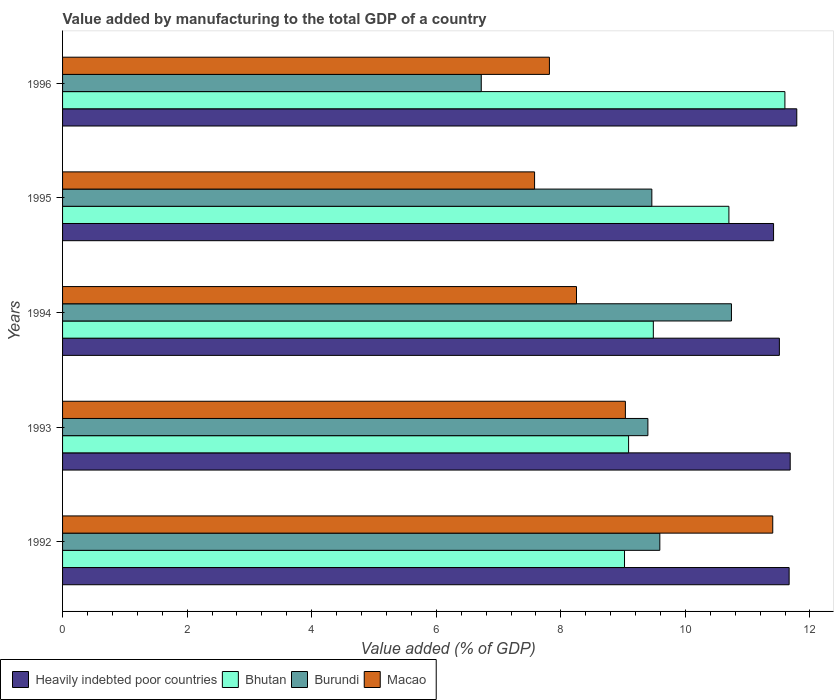How many groups of bars are there?
Your answer should be compact. 5. Are the number of bars per tick equal to the number of legend labels?
Provide a short and direct response. Yes. Are the number of bars on each tick of the Y-axis equal?
Make the answer very short. Yes. In how many cases, is the number of bars for a given year not equal to the number of legend labels?
Your answer should be compact. 0. What is the value added by manufacturing to the total GDP in Bhutan in 1995?
Provide a short and direct response. 10.7. Across all years, what is the maximum value added by manufacturing to the total GDP in Macao?
Offer a terse response. 11.4. Across all years, what is the minimum value added by manufacturing to the total GDP in Burundi?
Offer a very short reply. 6.72. What is the total value added by manufacturing to the total GDP in Macao in the graph?
Provide a short and direct response. 44.09. What is the difference between the value added by manufacturing to the total GDP in Burundi in 1993 and that in 1996?
Ensure brevity in your answer.  2.68. What is the difference between the value added by manufacturing to the total GDP in Burundi in 1993 and the value added by manufacturing to the total GDP in Macao in 1994?
Provide a short and direct response. 1.15. What is the average value added by manufacturing to the total GDP in Bhutan per year?
Offer a terse response. 9.98. In the year 1994, what is the difference between the value added by manufacturing to the total GDP in Bhutan and value added by manufacturing to the total GDP in Burundi?
Your answer should be very brief. -1.25. What is the ratio of the value added by manufacturing to the total GDP in Macao in 1993 to that in 1994?
Offer a very short reply. 1.1. Is the value added by manufacturing to the total GDP in Burundi in 1994 less than that in 1996?
Give a very brief answer. No. What is the difference between the highest and the second highest value added by manufacturing to the total GDP in Macao?
Your response must be concise. 2.37. What is the difference between the highest and the lowest value added by manufacturing to the total GDP in Macao?
Provide a succinct answer. 3.82. In how many years, is the value added by manufacturing to the total GDP in Heavily indebted poor countries greater than the average value added by manufacturing to the total GDP in Heavily indebted poor countries taken over all years?
Make the answer very short. 3. Is the sum of the value added by manufacturing to the total GDP in Macao in 1994 and 1996 greater than the maximum value added by manufacturing to the total GDP in Heavily indebted poor countries across all years?
Offer a terse response. Yes. What does the 4th bar from the top in 1992 represents?
Your response must be concise. Heavily indebted poor countries. What does the 1st bar from the bottom in 1993 represents?
Your response must be concise. Heavily indebted poor countries. Does the graph contain any zero values?
Provide a short and direct response. No. Does the graph contain grids?
Give a very brief answer. No. How many legend labels are there?
Your response must be concise. 4. How are the legend labels stacked?
Ensure brevity in your answer.  Horizontal. What is the title of the graph?
Your response must be concise. Value added by manufacturing to the total GDP of a country. Does "Least developed countries" appear as one of the legend labels in the graph?
Make the answer very short. No. What is the label or title of the X-axis?
Offer a very short reply. Value added (% of GDP). What is the label or title of the Y-axis?
Provide a succinct answer. Years. What is the Value added (% of GDP) in Heavily indebted poor countries in 1992?
Your response must be concise. 11.67. What is the Value added (% of GDP) of Bhutan in 1992?
Give a very brief answer. 9.02. What is the Value added (% of GDP) of Burundi in 1992?
Your answer should be compact. 9.59. What is the Value added (% of GDP) in Macao in 1992?
Your answer should be compact. 11.4. What is the Value added (% of GDP) of Heavily indebted poor countries in 1993?
Offer a very short reply. 11.68. What is the Value added (% of GDP) of Bhutan in 1993?
Provide a short and direct response. 9.09. What is the Value added (% of GDP) of Burundi in 1993?
Your answer should be compact. 9.4. What is the Value added (% of GDP) of Macao in 1993?
Provide a succinct answer. 9.04. What is the Value added (% of GDP) in Heavily indebted poor countries in 1994?
Give a very brief answer. 11.51. What is the Value added (% of GDP) of Bhutan in 1994?
Your response must be concise. 9.49. What is the Value added (% of GDP) of Burundi in 1994?
Your answer should be very brief. 10.74. What is the Value added (% of GDP) in Macao in 1994?
Keep it short and to the point. 8.25. What is the Value added (% of GDP) of Heavily indebted poor countries in 1995?
Provide a short and direct response. 11.42. What is the Value added (% of GDP) in Bhutan in 1995?
Your answer should be compact. 10.7. What is the Value added (% of GDP) in Burundi in 1995?
Give a very brief answer. 9.46. What is the Value added (% of GDP) of Macao in 1995?
Make the answer very short. 7.58. What is the Value added (% of GDP) in Heavily indebted poor countries in 1996?
Ensure brevity in your answer.  11.79. What is the Value added (% of GDP) of Bhutan in 1996?
Your answer should be compact. 11.6. What is the Value added (% of GDP) of Burundi in 1996?
Offer a terse response. 6.72. What is the Value added (% of GDP) of Macao in 1996?
Your answer should be compact. 7.82. Across all years, what is the maximum Value added (% of GDP) of Heavily indebted poor countries?
Offer a very short reply. 11.79. Across all years, what is the maximum Value added (% of GDP) of Bhutan?
Offer a very short reply. 11.6. Across all years, what is the maximum Value added (% of GDP) in Burundi?
Ensure brevity in your answer.  10.74. Across all years, what is the maximum Value added (% of GDP) of Macao?
Keep it short and to the point. 11.4. Across all years, what is the minimum Value added (% of GDP) in Heavily indebted poor countries?
Offer a very short reply. 11.42. Across all years, what is the minimum Value added (% of GDP) in Bhutan?
Offer a very short reply. 9.02. Across all years, what is the minimum Value added (% of GDP) of Burundi?
Make the answer very short. 6.72. Across all years, what is the minimum Value added (% of GDP) in Macao?
Provide a short and direct response. 7.58. What is the total Value added (% of GDP) in Heavily indebted poor countries in the graph?
Make the answer very short. 58.06. What is the total Value added (% of GDP) of Bhutan in the graph?
Your answer should be very brief. 49.89. What is the total Value added (% of GDP) in Burundi in the graph?
Your response must be concise. 45.91. What is the total Value added (% of GDP) in Macao in the graph?
Your answer should be compact. 44.09. What is the difference between the Value added (% of GDP) in Heavily indebted poor countries in 1992 and that in 1993?
Your answer should be compact. -0.02. What is the difference between the Value added (% of GDP) of Bhutan in 1992 and that in 1993?
Provide a short and direct response. -0.07. What is the difference between the Value added (% of GDP) of Burundi in 1992 and that in 1993?
Your answer should be compact. 0.19. What is the difference between the Value added (% of GDP) of Macao in 1992 and that in 1993?
Offer a very short reply. 2.37. What is the difference between the Value added (% of GDP) of Heavily indebted poor countries in 1992 and that in 1994?
Keep it short and to the point. 0.16. What is the difference between the Value added (% of GDP) of Bhutan in 1992 and that in 1994?
Ensure brevity in your answer.  -0.46. What is the difference between the Value added (% of GDP) in Burundi in 1992 and that in 1994?
Your response must be concise. -1.15. What is the difference between the Value added (% of GDP) of Macao in 1992 and that in 1994?
Your answer should be very brief. 3.15. What is the difference between the Value added (% of GDP) of Heavily indebted poor countries in 1992 and that in 1995?
Your response must be concise. 0.25. What is the difference between the Value added (% of GDP) of Bhutan in 1992 and that in 1995?
Your response must be concise. -1.68. What is the difference between the Value added (% of GDP) of Burundi in 1992 and that in 1995?
Provide a succinct answer. 0.13. What is the difference between the Value added (% of GDP) in Macao in 1992 and that in 1995?
Your answer should be very brief. 3.82. What is the difference between the Value added (% of GDP) of Heavily indebted poor countries in 1992 and that in 1996?
Give a very brief answer. -0.12. What is the difference between the Value added (% of GDP) in Bhutan in 1992 and that in 1996?
Keep it short and to the point. -2.58. What is the difference between the Value added (% of GDP) of Burundi in 1992 and that in 1996?
Make the answer very short. 2.87. What is the difference between the Value added (% of GDP) in Macao in 1992 and that in 1996?
Give a very brief answer. 3.59. What is the difference between the Value added (% of GDP) of Heavily indebted poor countries in 1993 and that in 1994?
Offer a terse response. 0.17. What is the difference between the Value added (% of GDP) of Bhutan in 1993 and that in 1994?
Provide a short and direct response. -0.4. What is the difference between the Value added (% of GDP) of Burundi in 1993 and that in 1994?
Provide a succinct answer. -1.34. What is the difference between the Value added (% of GDP) in Macao in 1993 and that in 1994?
Keep it short and to the point. 0.79. What is the difference between the Value added (% of GDP) in Heavily indebted poor countries in 1993 and that in 1995?
Make the answer very short. 0.27. What is the difference between the Value added (% of GDP) in Bhutan in 1993 and that in 1995?
Your response must be concise. -1.61. What is the difference between the Value added (% of GDP) of Burundi in 1993 and that in 1995?
Offer a very short reply. -0.06. What is the difference between the Value added (% of GDP) in Macao in 1993 and that in 1995?
Provide a short and direct response. 1.46. What is the difference between the Value added (% of GDP) of Heavily indebted poor countries in 1993 and that in 1996?
Your response must be concise. -0.11. What is the difference between the Value added (% of GDP) in Bhutan in 1993 and that in 1996?
Ensure brevity in your answer.  -2.51. What is the difference between the Value added (% of GDP) of Burundi in 1993 and that in 1996?
Your answer should be compact. 2.68. What is the difference between the Value added (% of GDP) of Macao in 1993 and that in 1996?
Give a very brief answer. 1.22. What is the difference between the Value added (% of GDP) of Heavily indebted poor countries in 1994 and that in 1995?
Make the answer very short. 0.09. What is the difference between the Value added (% of GDP) in Bhutan in 1994 and that in 1995?
Your answer should be very brief. -1.21. What is the difference between the Value added (% of GDP) of Burundi in 1994 and that in 1995?
Make the answer very short. 1.28. What is the difference between the Value added (% of GDP) in Macao in 1994 and that in 1995?
Keep it short and to the point. 0.67. What is the difference between the Value added (% of GDP) in Heavily indebted poor countries in 1994 and that in 1996?
Your answer should be very brief. -0.28. What is the difference between the Value added (% of GDP) of Bhutan in 1994 and that in 1996?
Your answer should be compact. -2.11. What is the difference between the Value added (% of GDP) of Burundi in 1994 and that in 1996?
Provide a succinct answer. 4.02. What is the difference between the Value added (% of GDP) of Macao in 1994 and that in 1996?
Provide a succinct answer. 0.43. What is the difference between the Value added (% of GDP) of Heavily indebted poor countries in 1995 and that in 1996?
Your answer should be compact. -0.37. What is the difference between the Value added (% of GDP) of Bhutan in 1995 and that in 1996?
Your response must be concise. -0.9. What is the difference between the Value added (% of GDP) of Burundi in 1995 and that in 1996?
Provide a short and direct response. 2.74. What is the difference between the Value added (% of GDP) of Macao in 1995 and that in 1996?
Offer a very short reply. -0.24. What is the difference between the Value added (% of GDP) of Heavily indebted poor countries in 1992 and the Value added (% of GDP) of Bhutan in 1993?
Ensure brevity in your answer.  2.58. What is the difference between the Value added (% of GDP) of Heavily indebted poor countries in 1992 and the Value added (% of GDP) of Burundi in 1993?
Offer a very short reply. 2.27. What is the difference between the Value added (% of GDP) of Heavily indebted poor countries in 1992 and the Value added (% of GDP) of Macao in 1993?
Ensure brevity in your answer.  2.63. What is the difference between the Value added (% of GDP) in Bhutan in 1992 and the Value added (% of GDP) in Burundi in 1993?
Ensure brevity in your answer.  -0.38. What is the difference between the Value added (% of GDP) of Bhutan in 1992 and the Value added (% of GDP) of Macao in 1993?
Your answer should be very brief. -0.01. What is the difference between the Value added (% of GDP) in Burundi in 1992 and the Value added (% of GDP) in Macao in 1993?
Keep it short and to the point. 0.55. What is the difference between the Value added (% of GDP) in Heavily indebted poor countries in 1992 and the Value added (% of GDP) in Bhutan in 1994?
Ensure brevity in your answer.  2.18. What is the difference between the Value added (% of GDP) in Heavily indebted poor countries in 1992 and the Value added (% of GDP) in Burundi in 1994?
Give a very brief answer. 0.93. What is the difference between the Value added (% of GDP) of Heavily indebted poor countries in 1992 and the Value added (% of GDP) of Macao in 1994?
Ensure brevity in your answer.  3.41. What is the difference between the Value added (% of GDP) in Bhutan in 1992 and the Value added (% of GDP) in Burundi in 1994?
Make the answer very short. -1.72. What is the difference between the Value added (% of GDP) in Bhutan in 1992 and the Value added (% of GDP) in Macao in 1994?
Offer a very short reply. 0.77. What is the difference between the Value added (% of GDP) in Burundi in 1992 and the Value added (% of GDP) in Macao in 1994?
Your answer should be very brief. 1.34. What is the difference between the Value added (% of GDP) of Heavily indebted poor countries in 1992 and the Value added (% of GDP) of Bhutan in 1995?
Your response must be concise. 0.97. What is the difference between the Value added (% of GDP) in Heavily indebted poor countries in 1992 and the Value added (% of GDP) in Burundi in 1995?
Make the answer very short. 2.2. What is the difference between the Value added (% of GDP) in Heavily indebted poor countries in 1992 and the Value added (% of GDP) in Macao in 1995?
Make the answer very short. 4.09. What is the difference between the Value added (% of GDP) in Bhutan in 1992 and the Value added (% of GDP) in Burundi in 1995?
Offer a terse response. -0.44. What is the difference between the Value added (% of GDP) in Bhutan in 1992 and the Value added (% of GDP) in Macao in 1995?
Your answer should be very brief. 1.44. What is the difference between the Value added (% of GDP) in Burundi in 1992 and the Value added (% of GDP) in Macao in 1995?
Ensure brevity in your answer.  2.01. What is the difference between the Value added (% of GDP) in Heavily indebted poor countries in 1992 and the Value added (% of GDP) in Bhutan in 1996?
Provide a succinct answer. 0.07. What is the difference between the Value added (% of GDP) in Heavily indebted poor countries in 1992 and the Value added (% of GDP) in Burundi in 1996?
Provide a succinct answer. 4.94. What is the difference between the Value added (% of GDP) in Heavily indebted poor countries in 1992 and the Value added (% of GDP) in Macao in 1996?
Ensure brevity in your answer.  3.85. What is the difference between the Value added (% of GDP) in Bhutan in 1992 and the Value added (% of GDP) in Burundi in 1996?
Your response must be concise. 2.3. What is the difference between the Value added (% of GDP) of Bhutan in 1992 and the Value added (% of GDP) of Macao in 1996?
Your response must be concise. 1.21. What is the difference between the Value added (% of GDP) of Burundi in 1992 and the Value added (% of GDP) of Macao in 1996?
Make the answer very short. 1.77. What is the difference between the Value added (% of GDP) of Heavily indebted poor countries in 1993 and the Value added (% of GDP) of Bhutan in 1994?
Your response must be concise. 2.2. What is the difference between the Value added (% of GDP) in Heavily indebted poor countries in 1993 and the Value added (% of GDP) in Burundi in 1994?
Ensure brevity in your answer.  0.94. What is the difference between the Value added (% of GDP) of Heavily indebted poor countries in 1993 and the Value added (% of GDP) of Macao in 1994?
Keep it short and to the point. 3.43. What is the difference between the Value added (% of GDP) in Bhutan in 1993 and the Value added (% of GDP) in Burundi in 1994?
Your answer should be compact. -1.65. What is the difference between the Value added (% of GDP) in Bhutan in 1993 and the Value added (% of GDP) in Macao in 1994?
Offer a terse response. 0.84. What is the difference between the Value added (% of GDP) of Burundi in 1993 and the Value added (% of GDP) of Macao in 1994?
Ensure brevity in your answer.  1.15. What is the difference between the Value added (% of GDP) in Heavily indebted poor countries in 1993 and the Value added (% of GDP) in Bhutan in 1995?
Provide a succinct answer. 0.98. What is the difference between the Value added (% of GDP) of Heavily indebted poor countries in 1993 and the Value added (% of GDP) of Burundi in 1995?
Your answer should be very brief. 2.22. What is the difference between the Value added (% of GDP) of Heavily indebted poor countries in 1993 and the Value added (% of GDP) of Macao in 1995?
Ensure brevity in your answer.  4.1. What is the difference between the Value added (% of GDP) of Bhutan in 1993 and the Value added (% of GDP) of Burundi in 1995?
Offer a terse response. -0.37. What is the difference between the Value added (% of GDP) of Bhutan in 1993 and the Value added (% of GDP) of Macao in 1995?
Your answer should be compact. 1.51. What is the difference between the Value added (% of GDP) in Burundi in 1993 and the Value added (% of GDP) in Macao in 1995?
Your answer should be very brief. 1.82. What is the difference between the Value added (% of GDP) in Heavily indebted poor countries in 1993 and the Value added (% of GDP) in Bhutan in 1996?
Your answer should be very brief. 0.09. What is the difference between the Value added (% of GDP) of Heavily indebted poor countries in 1993 and the Value added (% of GDP) of Burundi in 1996?
Your answer should be very brief. 4.96. What is the difference between the Value added (% of GDP) in Heavily indebted poor countries in 1993 and the Value added (% of GDP) in Macao in 1996?
Your answer should be very brief. 3.87. What is the difference between the Value added (% of GDP) in Bhutan in 1993 and the Value added (% of GDP) in Burundi in 1996?
Your response must be concise. 2.37. What is the difference between the Value added (% of GDP) of Bhutan in 1993 and the Value added (% of GDP) of Macao in 1996?
Your response must be concise. 1.27. What is the difference between the Value added (% of GDP) of Burundi in 1993 and the Value added (% of GDP) of Macao in 1996?
Make the answer very short. 1.58. What is the difference between the Value added (% of GDP) in Heavily indebted poor countries in 1994 and the Value added (% of GDP) in Bhutan in 1995?
Your response must be concise. 0.81. What is the difference between the Value added (% of GDP) of Heavily indebted poor countries in 1994 and the Value added (% of GDP) of Burundi in 1995?
Offer a very short reply. 2.05. What is the difference between the Value added (% of GDP) of Heavily indebted poor countries in 1994 and the Value added (% of GDP) of Macao in 1995?
Provide a succinct answer. 3.93. What is the difference between the Value added (% of GDP) in Bhutan in 1994 and the Value added (% of GDP) in Burundi in 1995?
Provide a short and direct response. 0.02. What is the difference between the Value added (% of GDP) in Bhutan in 1994 and the Value added (% of GDP) in Macao in 1995?
Offer a very short reply. 1.91. What is the difference between the Value added (% of GDP) in Burundi in 1994 and the Value added (% of GDP) in Macao in 1995?
Your response must be concise. 3.16. What is the difference between the Value added (% of GDP) of Heavily indebted poor countries in 1994 and the Value added (% of GDP) of Bhutan in 1996?
Make the answer very short. -0.09. What is the difference between the Value added (% of GDP) of Heavily indebted poor countries in 1994 and the Value added (% of GDP) of Burundi in 1996?
Make the answer very short. 4.79. What is the difference between the Value added (% of GDP) of Heavily indebted poor countries in 1994 and the Value added (% of GDP) of Macao in 1996?
Ensure brevity in your answer.  3.69. What is the difference between the Value added (% of GDP) in Bhutan in 1994 and the Value added (% of GDP) in Burundi in 1996?
Provide a short and direct response. 2.76. What is the difference between the Value added (% of GDP) in Bhutan in 1994 and the Value added (% of GDP) in Macao in 1996?
Give a very brief answer. 1.67. What is the difference between the Value added (% of GDP) of Burundi in 1994 and the Value added (% of GDP) of Macao in 1996?
Keep it short and to the point. 2.92. What is the difference between the Value added (% of GDP) of Heavily indebted poor countries in 1995 and the Value added (% of GDP) of Bhutan in 1996?
Give a very brief answer. -0.18. What is the difference between the Value added (% of GDP) of Heavily indebted poor countries in 1995 and the Value added (% of GDP) of Burundi in 1996?
Give a very brief answer. 4.69. What is the difference between the Value added (% of GDP) in Heavily indebted poor countries in 1995 and the Value added (% of GDP) in Macao in 1996?
Ensure brevity in your answer.  3.6. What is the difference between the Value added (% of GDP) of Bhutan in 1995 and the Value added (% of GDP) of Burundi in 1996?
Provide a succinct answer. 3.98. What is the difference between the Value added (% of GDP) in Bhutan in 1995 and the Value added (% of GDP) in Macao in 1996?
Your answer should be very brief. 2.88. What is the difference between the Value added (% of GDP) in Burundi in 1995 and the Value added (% of GDP) in Macao in 1996?
Ensure brevity in your answer.  1.64. What is the average Value added (% of GDP) of Heavily indebted poor countries per year?
Make the answer very short. 11.61. What is the average Value added (% of GDP) of Bhutan per year?
Your answer should be compact. 9.98. What is the average Value added (% of GDP) of Burundi per year?
Provide a succinct answer. 9.18. What is the average Value added (% of GDP) in Macao per year?
Make the answer very short. 8.82. In the year 1992, what is the difference between the Value added (% of GDP) of Heavily indebted poor countries and Value added (% of GDP) of Bhutan?
Your response must be concise. 2.64. In the year 1992, what is the difference between the Value added (% of GDP) in Heavily indebted poor countries and Value added (% of GDP) in Burundi?
Make the answer very short. 2.08. In the year 1992, what is the difference between the Value added (% of GDP) of Heavily indebted poor countries and Value added (% of GDP) of Macao?
Ensure brevity in your answer.  0.26. In the year 1992, what is the difference between the Value added (% of GDP) in Bhutan and Value added (% of GDP) in Burundi?
Provide a short and direct response. -0.57. In the year 1992, what is the difference between the Value added (% of GDP) in Bhutan and Value added (% of GDP) in Macao?
Ensure brevity in your answer.  -2.38. In the year 1992, what is the difference between the Value added (% of GDP) in Burundi and Value added (% of GDP) in Macao?
Your answer should be very brief. -1.81. In the year 1993, what is the difference between the Value added (% of GDP) of Heavily indebted poor countries and Value added (% of GDP) of Bhutan?
Offer a very short reply. 2.59. In the year 1993, what is the difference between the Value added (% of GDP) of Heavily indebted poor countries and Value added (% of GDP) of Burundi?
Provide a short and direct response. 2.29. In the year 1993, what is the difference between the Value added (% of GDP) in Heavily indebted poor countries and Value added (% of GDP) in Macao?
Ensure brevity in your answer.  2.65. In the year 1993, what is the difference between the Value added (% of GDP) in Bhutan and Value added (% of GDP) in Burundi?
Ensure brevity in your answer.  -0.31. In the year 1993, what is the difference between the Value added (% of GDP) of Bhutan and Value added (% of GDP) of Macao?
Provide a short and direct response. 0.05. In the year 1993, what is the difference between the Value added (% of GDP) in Burundi and Value added (% of GDP) in Macao?
Ensure brevity in your answer.  0.36. In the year 1994, what is the difference between the Value added (% of GDP) of Heavily indebted poor countries and Value added (% of GDP) of Bhutan?
Your answer should be very brief. 2.02. In the year 1994, what is the difference between the Value added (% of GDP) in Heavily indebted poor countries and Value added (% of GDP) in Burundi?
Your response must be concise. 0.77. In the year 1994, what is the difference between the Value added (% of GDP) of Heavily indebted poor countries and Value added (% of GDP) of Macao?
Ensure brevity in your answer.  3.26. In the year 1994, what is the difference between the Value added (% of GDP) of Bhutan and Value added (% of GDP) of Burundi?
Ensure brevity in your answer.  -1.25. In the year 1994, what is the difference between the Value added (% of GDP) of Bhutan and Value added (% of GDP) of Macao?
Make the answer very short. 1.23. In the year 1994, what is the difference between the Value added (% of GDP) of Burundi and Value added (% of GDP) of Macao?
Your answer should be compact. 2.49. In the year 1995, what is the difference between the Value added (% of GDP) of Heavily indebted poor countries and Value added (% of GDP) of Bhutan?
Your answer should be very brief. 0.72. In the year 1995, what is the difference between the Value added (% of GDP) in Heavily indebted poor countries and Value added (% of GDP) in Burundi?
Your answer should be very brief. 1.95. In the year 1995, what is the difference between the Value added (% of GDP) of Heavily indebted poor countries and Value added (% of GDP) of Macao?
Keep it short and to the point. 3.84. In the year 1995, what is the difference between the Value added (% of GDP) of Bhutan and Value added (% of GDP) of Burundi?
Your answer should be very brief. 1.24. In the year 1995, what is the difference between the Value added (% of GDP) in Bhutan and Value added (% of GDP) in Macao?
Provide a short and direct response. 3.12. In the year 1995, what is the difference between the Value added (% of GDP) in Burundi and Value added (% of GDP) in Macao?
Give a very brief answer. 1.88. In the year 1996, what is the difference between the Value added (% of GDP) of Heavily indebted poor countries and Value added (% of GDP) of Bhutan?
Keep it short and to the point. 0.19. In the year 1996, what is the difference between the Value added (% of GDP) in Heavily indebted poor countries and Value added (% of GDP) in Burundi?
Your response must be concise. 5.07. In the year 1996, what is the difference between the Value added (% of GDP) of Heavily indebted poor countries and Value added (% of GDP) of Macao?
Give a very brief answer. 3.97. In the year 1996, what is the difference between the Value added (% of GDP) in Bhutan and Value added (% of GDP) in Burundi?
Your answer should be very brief. 4.88. In the year 1996, what is the difference between the Value added (% of GDP) of Bhutan and Value added (% of GDP) of Macao?
Provide a succinct answer. 3.78. In the year 1996, what is the difference between the Value added (% of GDP) of Burundi and Value added (% of GDP) of Macao?
Give a very brief answer. -1.09. What is the ratio of the Value added (% of GDP) of Heavily indebted poor countries in 1992 to that in 1993?
Your response must be concise. 1. What is the ratio of the Value added (% of GDP) in Burundi in 1992 to that in 1993?
Ensure brevity in your answer.  1.02. What is the ratio of the Value added (% of GDP) of Macao in 1992 to that in 1993?
Make the answer very short. 1.26. What is the ratio of the Value added (% of GDP) of Heavily indebted poor countries in 1992 to that in 1994?
Offer a very short reply. 1.01. What is the ratio of the Value added (% of GDP) in Bhutan in 1992 to that in 1994?
Keep it short and to the point. 0.95. What is the ratio of the Value added (% of GDP) of Burundi in 1992 to that in 1994?
Provide a short and direct response. 0.89. What is the ratio of the Value added (% of GDP) of Macao in 1992 to that in 1994?
Keep it short and to the point. 1.38. What is the ratio of the Value added (% of GDP) of Heavily indebted poor countries in 1992 to that in 1995?
Your answer should be compact. 1.02. What is the ratio of the Value added (% of GDP) in Bhutan in 1992 to that in 1995?
Your answer should be compact. 0.84. What is the ratio of the Value added (% of GDP) in Burundi in 1992 to that in 1995?
Provide a succinct answer. 1.01. What is the ratio of the Value added (% of GDP) in Macao in 1992 to that in 1995?
Provide a short and direct response. 1.5. What is the ratio of the Value added (% of GDP) of Bhutan in 1992 to that in 1996?
Give a very brief answer. 0.78. What is the ratio of the Value added (% of GDP) in Burundi in 1992 to that in 1996?
Your response must be concise. 1.43. What is the ratio of the Value added (% of GDP) of Macao in 1992 to that in 1996?
Make the answer very short. 1.46. What is the ratio of the Value added (% of GDP) of Heavily indebted poor countries in 1993 to that in 1994?
Provide a succinct answer. 1.02. What is the ratio of the Value added (% of GDP) of Bhutan in 1993 to that in 1994?
Make the answer very short. 0.96. What is the ratio of the Value added (% of GDP) in Burundi in 1993 to that in 1994?
Give a very brief answer. 0.88. What is the ratio of the Value added (% of GDP) of Macao in 1993 to that in 1994?
Provide a succinct answer. 1.1. What is the ratio of the Value added (% of GDP) of Heavily indebted poor countries in 1993 to that in 1995?
Your answer should be very brief. 1.02. What is the ratio of the Value added (% of GDP) in Bhutan in 1993 to that in 1995?
Provide a succinct answer. 0.85. What is the ratio of the Value added (% of GDP) of Macao in 1993 to that in 1995?
Provide a succinct answer. 1.19. What is the ratio of the Value added (% of GDP) in Heavily indebted poor countries in 1993 to that in 1996?
Give a very brief answer. 0.99. What is the ratio of the Value added (% of GDP) of Bhutan in 1993 to that in 1996?
Ensure brevity in your answer.  0.78. What is the ratio of the Value added (% of GDP) of Burundi in 1993 to that in 1996?
Make the answer very short. 1.4. What is the ratio of the Value added (% of GDP) of Macao in 1993 to that in 1996?
Offer a very short reply. 1.16. What is the ratio of the Value added (% of GDP) in Heavily indebted poor countries in 1994 to that in 1995?
Ensure brevity in your answer.  1.01. What is the ratio of the Value added (% of GDP) in Bhutan in 1994 to that in 1995?
Offer a terse response. 0.89. What is the ratio of the Value added (% of GDP) of Burundi in 1994 to that in 1995?
Provide a short and direct response. 1.14. What is the ratio of the Value added (% of GDP) in Macao in 1994 to that in 1995?
Give a very brief answer. 1.09. What is the ratio of the Value added (% of GDP) of Heavily indebted poor countries in 1994 to that in 1996?
Your answer should be compact. 0.98. What is the ratio of the Value added (% of GDP) of Bhutan in 1994 to that in 1996?
Provide a succinct answer. 0.82. What is the ratio of the Value added (% of GDP) in Burundi in 1994 to that in 1996?
Make the answer very short. 1.6. What is the ratio of the Value added (% of GDP) of Macao in 1994 to that in 1996?
Give a very brief answer. 1.06. What is the ratio of the Value added (% of GDP) of Heavily indebted poor countries in 1995 to that in 1996?
Give a very brief answer. 0.97. What is the ratio of the Value added (% of GDP) in Bhutan in 1995 to that in 1996?
Keep it short and to the point. 0.92. What is the ratio of the Value added (% of GDP) of Burundi in 1995 to that in 1996?
Your response must be concise. 1.41. What is the ratio of the Value added (% of GDP) in Macao in 1995 to that in 1996?
Provide a short and direct response. 0.97. What is the difference between the highest and the second highest Value added (% of GDP) in Heavily indebted poor countries?
Your answer should be compact. 0.11. What is the difference between the highest and the second highest Value added (% of GDP) of Bhutan?
Give a very brief answer. 0.9. What is the difference between the highest and the second highest Value added (% of GDP) of Burundi?
Offer a terse response. 1.15. What is the difference between the highest and the second highest Value added (% of GDP) in Macao?
Provide a succinct answer. 2.37. What is the difference between the highest and the lowest Value added (% of GDP) in Heavily indebted poor countries?
Provide a succinct answer. 0.37. What is the difference between the highest and the lowest Value added (% of GDP) of Bhutan?
Provide a short and direct response. 2.58. What is the difference between the highest and the lowest Value added (% of GDP) of Burundi?
Ensure brevity in your answer.  4.02. What is the difference between the highest and the lowest Value added (% of GDP) in Macao?
Offer a very short reply. 3.82. 